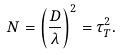Convert formula to latex. <formula><loc_0><loc_0><loc_500><loc_500>N = \left ( \frac { D } { \lambda } \right ) ^ { 2 } = \tau _ { T } ^ { 2 } .</formula> 